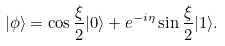<formula> <loc_0><loc_0><loc_500><loc_500>| \phi \rangle = \cos \frac { \xi } { 2 } | 0 \rangle + e ^ { - i \eta } \sin \frac { \xi } { 2 } | 1 \rangle .</formula> 